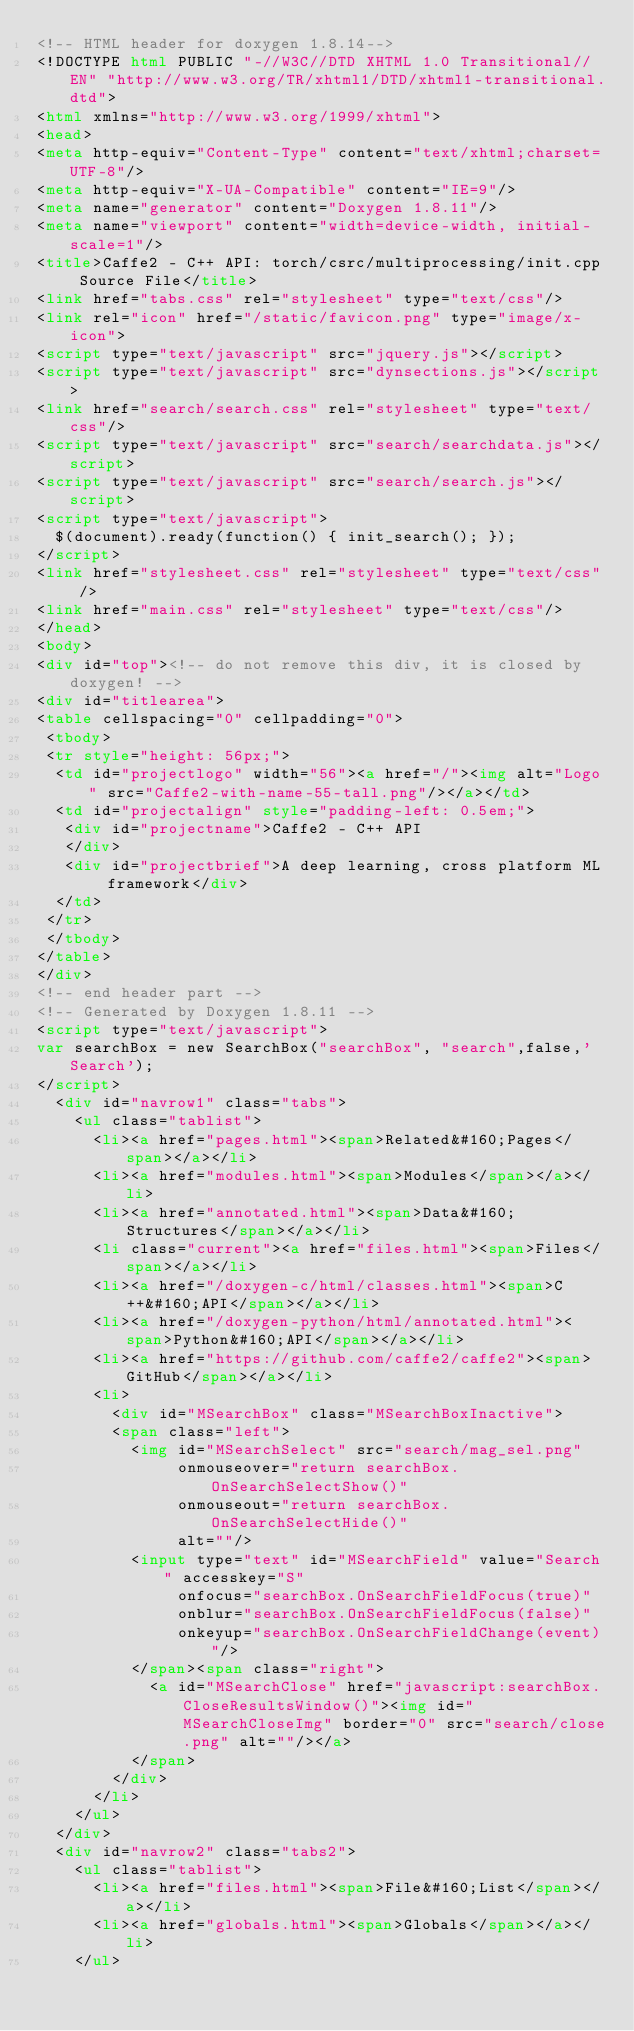Convert code to text. <code><loc_0><loc_0><loc_500><loc_500><_HTML_><!-- HTML header for doxygen 1.8.14-->
<!DOCTYPE html PUBLIC "-//W3C//DTD XHTML 1.0 Transitional//EN" "http://www.w3.org/TR/xhtml1/DTD/xhtml1-transitional.dtd">
<html xmlns="http://www.w3.org/1999/xhtml">
<head>
<meta http-equiv="Content-Type" content="text/xhtml;charset=UTF-8"/>
<meta http-equiv="X-UA-Compatible" content="IE=9"/>
<meta name="generator" content="Doxygen 1.8.11"/>
<meta name="viewport" content="width=device-width, initial-scale=1"/>
<title>Caffe2 - C++ API: torch/csrc/multiprocessing/init.cpp Source File</title>
<link href="tabs.css" rel="stylesheet" type="text/css"/>
<link rel="icon" href="/static/favicon.png" type="image/x-icon">
<script type="text/javascript" src="jquery.js"></script>
<script type="text/javascript" src="dynsections.js"></script>
<link href="search/search.css" rel="stylesheet" type="text/css"/>
<script type="text/javascript" src="search/searchdata.js"></script>
<script type="text/javascript" src="search/search.js"></script>
<script type="text/javascript">
  $(document).ready(function() { init_search(); });
</script>
<link href="stylesheet.css" rel="stylesheet" type="text/css" />
<link href="main.css" rel="stylesheet" type="text/css"/>
</head>
<body>
<div id="top"><!-- do not remove this div, it is closed by doxygen! -->
<div id="titlearea">
<table cellspacing="0" cellpadding="0">
 <tbody>
 <tr style="height: 56px;">
  <td id="projectlogo" width="56"><a href="/"><img alt="Logo" src="Caffe2-with-name-55-tall.png"/></a></td>
  <td id="projectalign" style="padding-left: 0.5em;">
   <div id="projectname">Caffe2 - C++ API
   </div>
   <div id="projectbrief">A deep learning, cross platform ML framework</div>
  </td>
 </tr>
 </tbody>
</table>
</div>
<!-- end header part -->
<!-- Generated by Doxygen 1.8.11 -->
<script type="text/javascript">
var searchBox = new SearchBox("searchBox", "search",false,'Search');
</script>
  <div id="navrow1" class="tabs">
    <ul class="tablist">
      <li><a href="pages.html"><span>Related&#160;Pages</span></a></li>
      <li><a href="modules.html"><span>Modules</span></a></li>
      <li><a href="annotated.html"><span>Data&#160;Structures</span></a></li>
      <li class="current"><a href="files.html"><span>Files</span></a></li>
      <li><a href="/doxygen-c/html/classes.html"><span>C++&#160;API</span></a></li>
      <li><a href="/doxygen-python/html/annotated.html"><span>Python&#160;API</span></a></li>
      <li><a href="https://github.com/caffe2/caffe2"><span>GitHub</span></a></li>
      <li>
        <div id="MSearchBox" class="MSearchBoxInactive">
        <span class="left">
          <img id="MSearchSelect" src="search/mag_sel.png"
               onmouseover="return searchBox.OnSearchSelectShow()"
               onmouseout="return searchBox.OnSearchSelectHide()"
               alt=""/>
          <input type="text" id="MSearchField" value="Search" accesskey="S"
               onfocus="searchBox.OnSearchFieldFocus(true)" 
               onblur="searchBox.OnSearchFieldFocus(false)" 
               onkeyup="searchBox.OnSearchFieldChange(event)"/>
          </span><span class="right">
            <a id="MSearchClose" href="javascript:searchBox.CloseResultsWindow()"><img id="MSearchCloseImg" border="0" src="search/close.png" alt=""/></a>
          </span>
        </div>
      </li>
    </ul>
  </div>
  <div id="navrow2" class="tabs2">
    <ul class="tablist">
      <li><a href="files.html"><span>File&#160;List</span></a></li>
      <li><a href="globals.html"><span>Globals</span></a></li>
    </ul></code> 